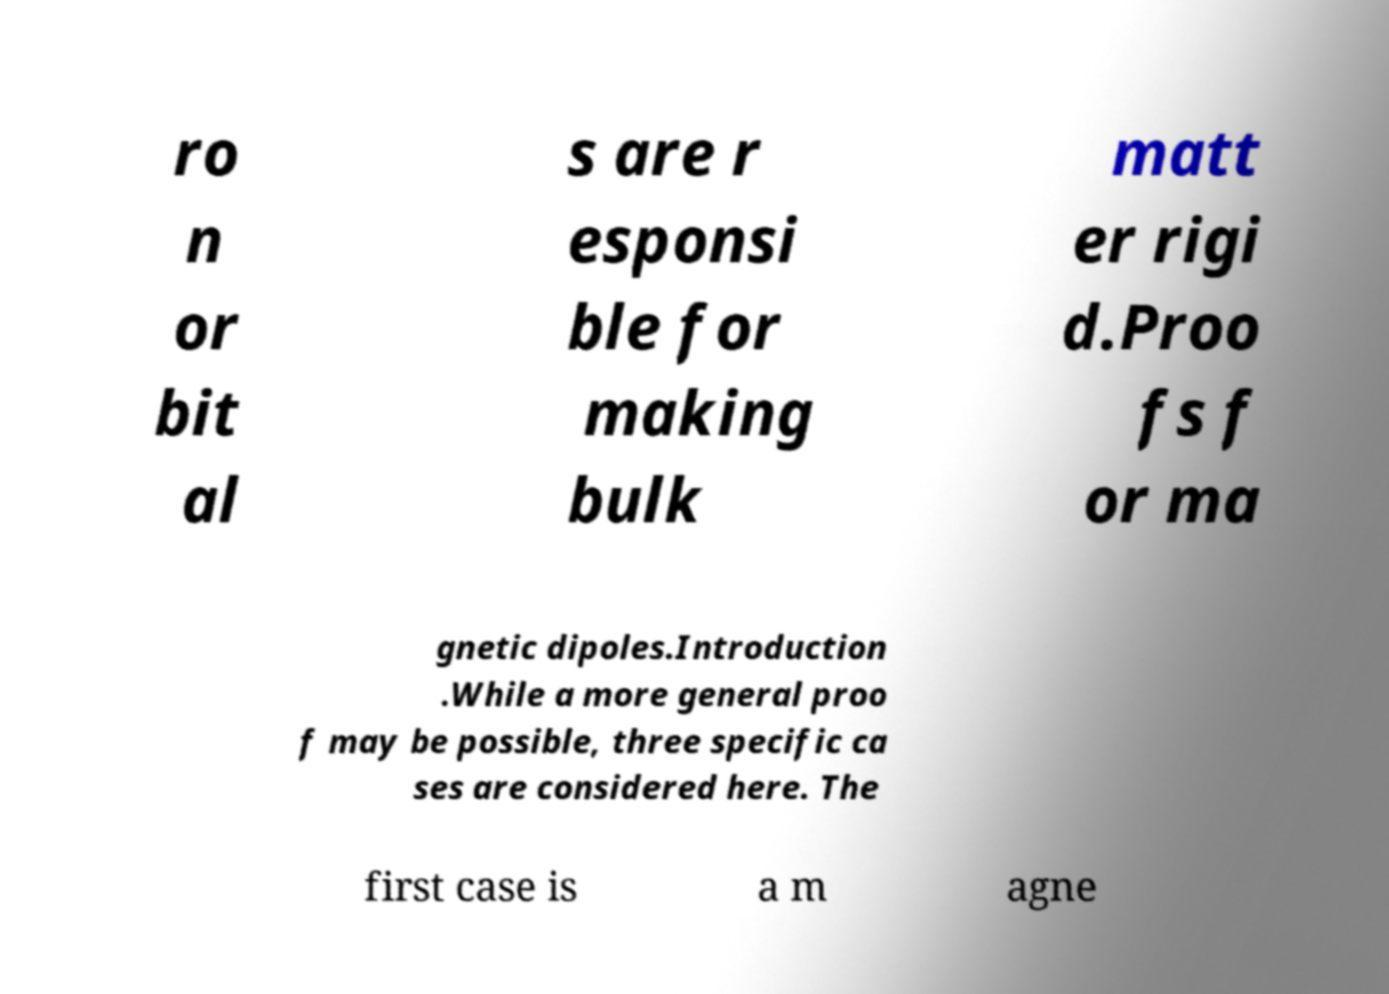For documentation purposes, I need the text within this image transcribed. Could you provide that? ro n or bit al s are r esponsi ble for making bulk matt er rigi d.Proo fs f or ma gnetic dipoles.Introduction .While a more general proo f may be possible, three specific ca ses are considered here. The first case is a m agne 